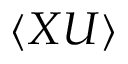Convert formula to latex. <formula><loc_0><loc_0><loc_500><loc_500>\langle X U \rangle</formula> 